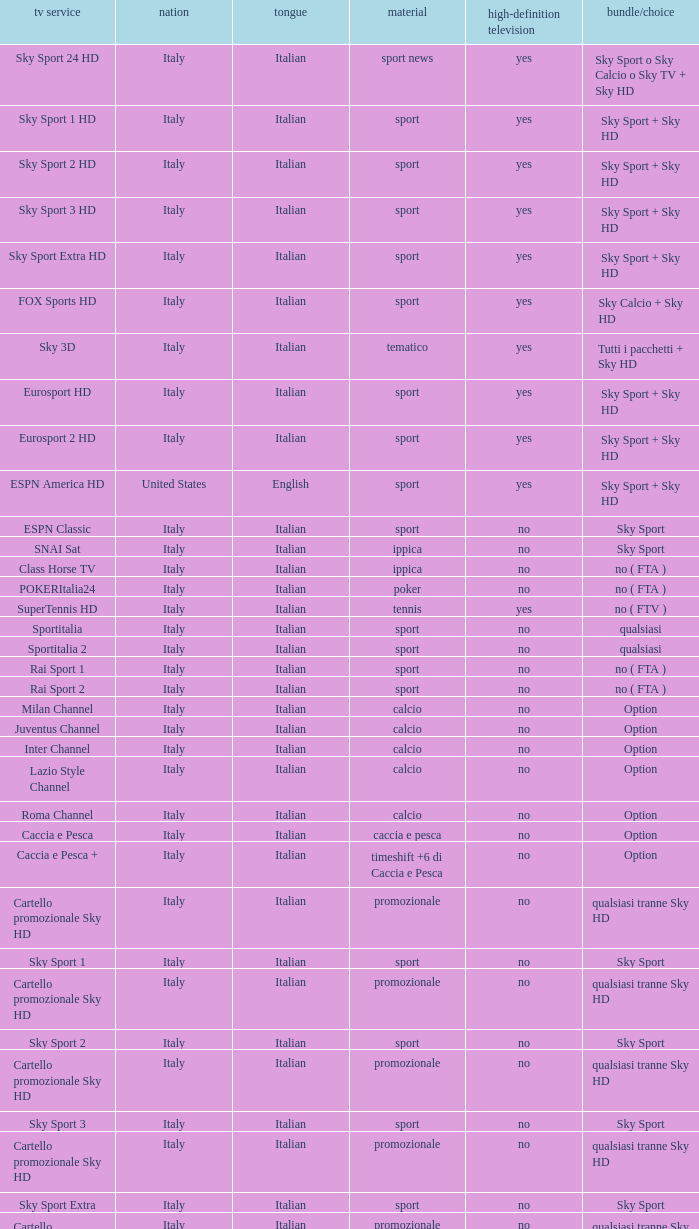What is Language, when Content is Sport, when HDTV is No, and when Television Service is ESPN America? Italian. 